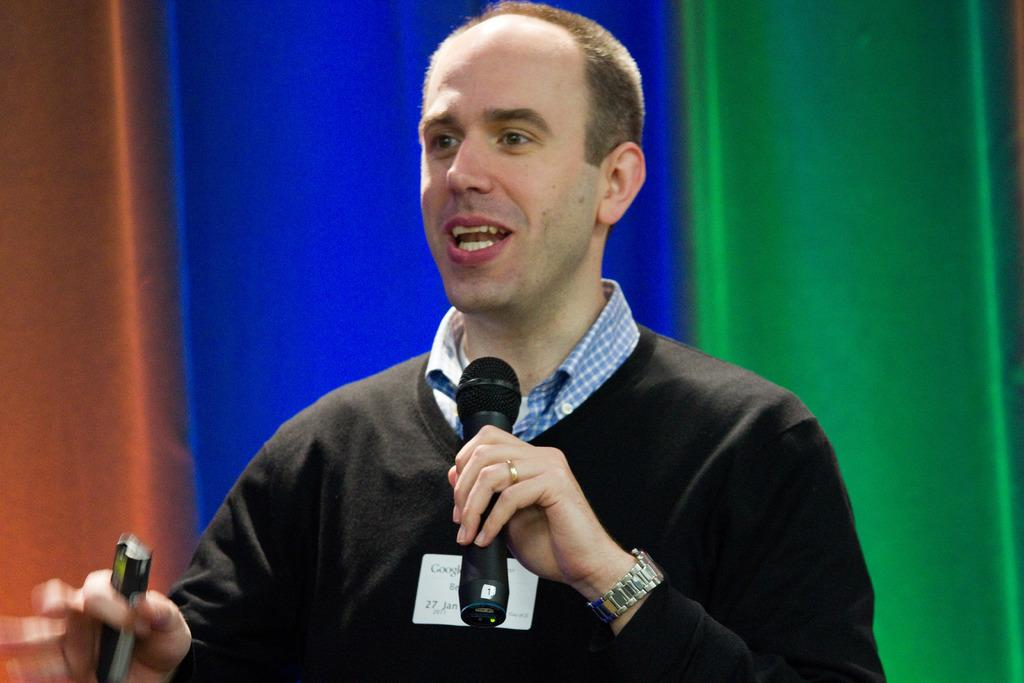What is the main subject of the image? The main subject of the image is a man. What is the man doing in the image? The man is speaking in the image. What object is the man holding while speaking? The man is holding a microphone. What is the man wearing on his upper body? The man is wearing a black t-shirt. What accessory is the man wearing on his wrist? The man is wearing a watch. How would you describe the background of the image? The background of the image is blurry. What type of polish is the man applying to his nails in the image? There is no indication in the image that the man is applying polish to his nails; he is holding a microphone and speaking. 